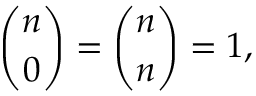Convert formula to latex. <formula><loc_0><loc_0><loc_500><loc_500>{ \binom { n } { 0 } } = { \binom { n } { n } } = 1 ,</formula> 